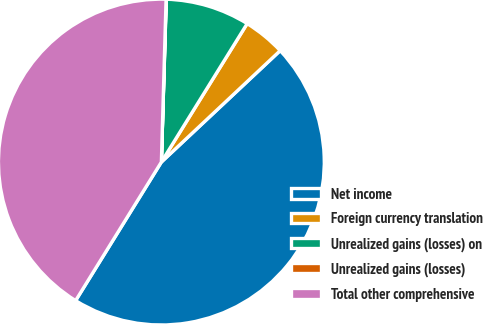<chart> <loc_0><loc_0><loc_500><loc_500><pie_chart><fcel>Net income<fcel>Foreign currency translation<fcel>Unrealized gains (losses) on<fcel>Unrealized gains (losses)<fcel>Total other comprehensive<nl><fcel>45.81%<fcel>4.18%<fcel>8.35%<fcel>0.02%<fcel>41.64%<nl></chart> 